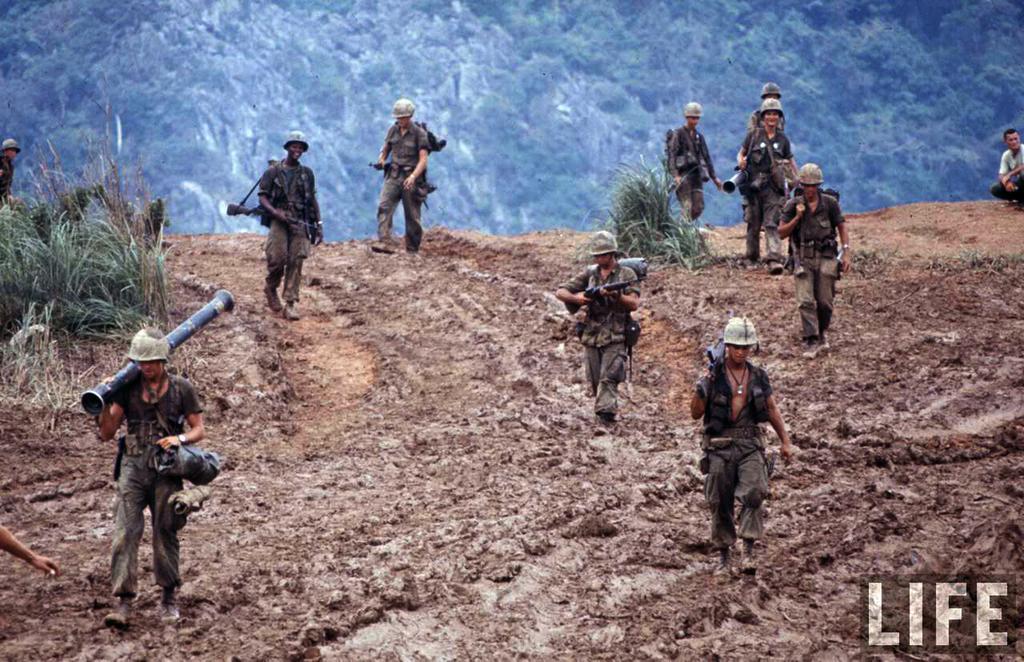Can you describe this image briefly? In this picture we can see group of people, few people wore helmets and few people holding weapons, beside to them we can see few plants, in the background we can find few trees, and also we can see a watermark at the right bottom of the image. 